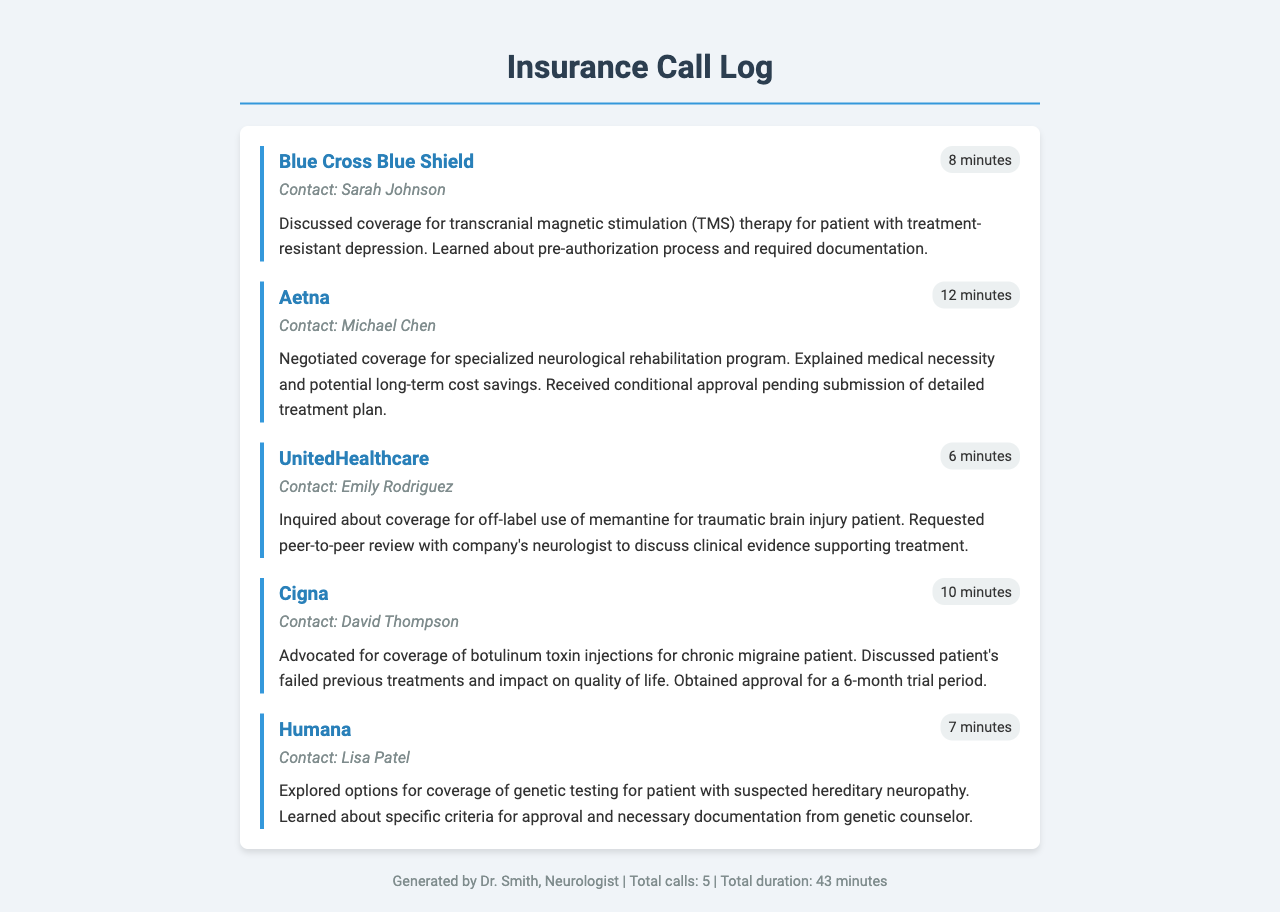What is the name of the patient’s insurance provider discussed in this log? The log details calls made to various insurance companies for coverage negotiations, including Blue Cross Blue Shield, Aetna, UnitedHealthcare, Cigna, and Humana.
Answer: Blue Cross Blue Shield, Aetna, UnitedHealthcare, Cigna, Humana Who did Dr. Smith speak to at Aetna? In the document, the contact person for Aetna is mentioned during the call entry for the negotiation of coverage for specialized neurological rehabilitation.
Answer: Michael Chen How long was the call with UnitedHealthcare? The document records the duration of the call with UnitedHealthcare as part of the call entry.
Answer: 6 minutes What specific therapy was discussed with Blue Cross Blue Shield? The summary for the call with Blue Cross Blue Shield indicates the therapy discussed was transcranial magnetic stimulation (TMS) for treatment-resistant depression.
Answer: transcranial magnetic stimulation (TMS) What approval did Dr. Smith obtain from Cigna? In the Cigna entry, it specifies that Dr. Smith obtained an approval for botulinum toxin injections for a chronic migraine patient, with a particular trial duration.
Answer: 6-month trial period 